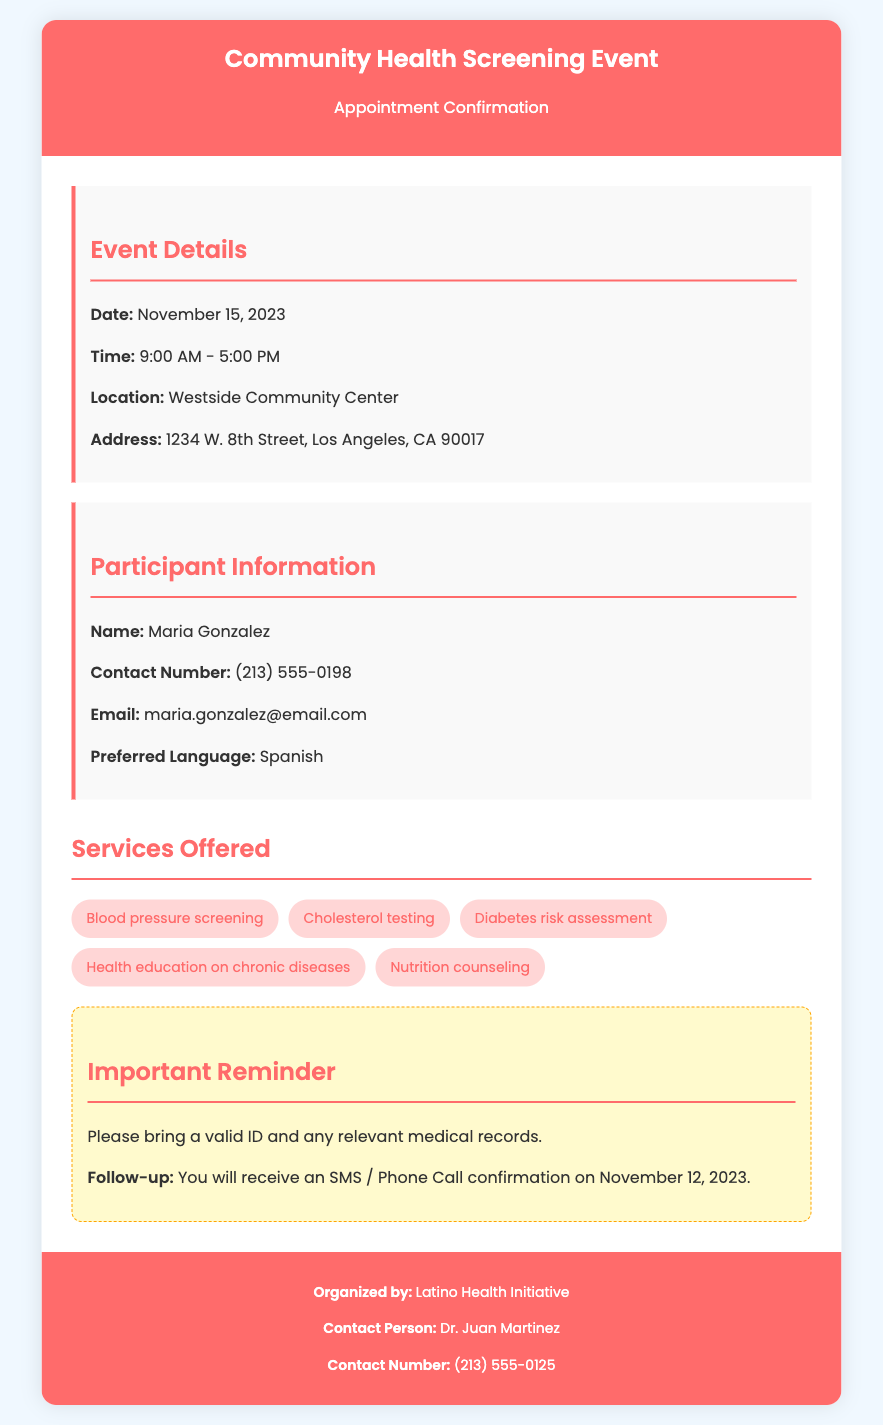What is the date of the event? The date of the event is explicitly stated in the document as November 15, 2023.
Answer: November 15, 2023 What is the time of the appointment? The time of the appointment is provided in the event details section as 9:00 AM - 5:00 PM.
Answer: 9:00 AM - 5:00 PM What is the name of the participant? The participant's name is clearly listed in the document under participant information as Maria Gonzalez.
Answer: Maria Gonzalez What services are offered at the event? Services offered at the event are listed and include blood pressure screening, cholesterol testing, diabetes risk assessment, health education on chronic diseases, and nutrition counseling.
Answer: Blood pressure screening, cholesterol testing, diabetes risk assessment, health education on chronic diseases, nutrition counseling What is the contact number for follow-up? The document states the contact number for follow-up, which is specified under the contact person section as (213) 555-0125.
Answer: (213) 555-0125 Why is it important to bring a valid ID? The document includes an important reminder which states to bring a valid ID for the screening event.
Answer: It is requested in the reminder section When will the participant receive a follow-up confirmation? The document specifies that an SMS / Phone Call confirmation will be sent on November 12, 2023.
Answer: November 12, 2023 Where is the event being held? The location of the event is clearly mentioned as Westside Community Center on 1234 W. 8th Street, Los Angeles, CA 90017.
Answer: Westside Community Center, 1234 W. 8th Street, Los Angeles, CA 90017 What is the preferred language of the participant? The preferred language of the participant is indicated in the document as Spanish.
Answer: Spanish 